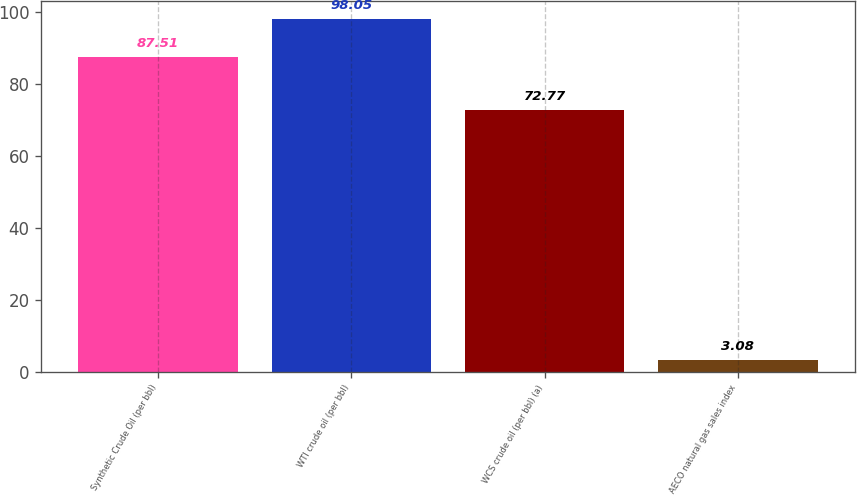<chart> <loc_0><loc_0><loc_500><loc_500><bar_chart><fcel>Synthetic Crude Oil (per bbl)<fcel>WTI crude oil (per bbl)<fcel>WCS crude oil (per bbl) (a)<fcel>AECO natural gas sales index<nl><fcel>87.51<fcel>98.05<fcel>72.77<fcel>3.08<nl></chart> 